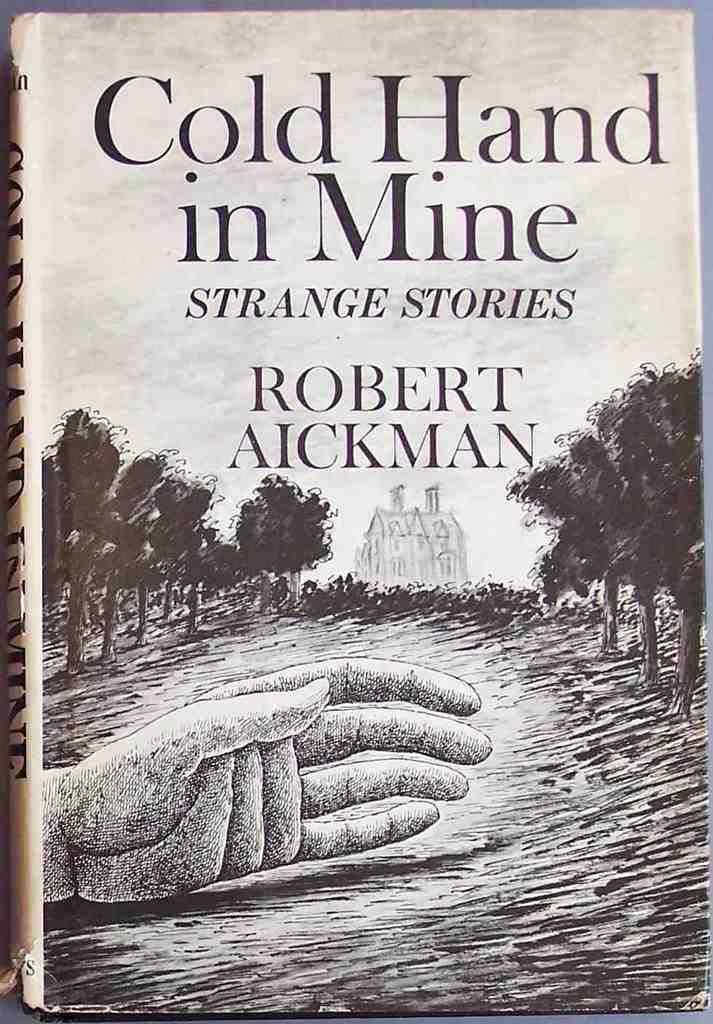In one or two sentences, can you explain what this image depicts? In this image we can see the cover page of a book. In the image there is a hand in the middle. In the background there is a building. There are trees on either side of the building. 